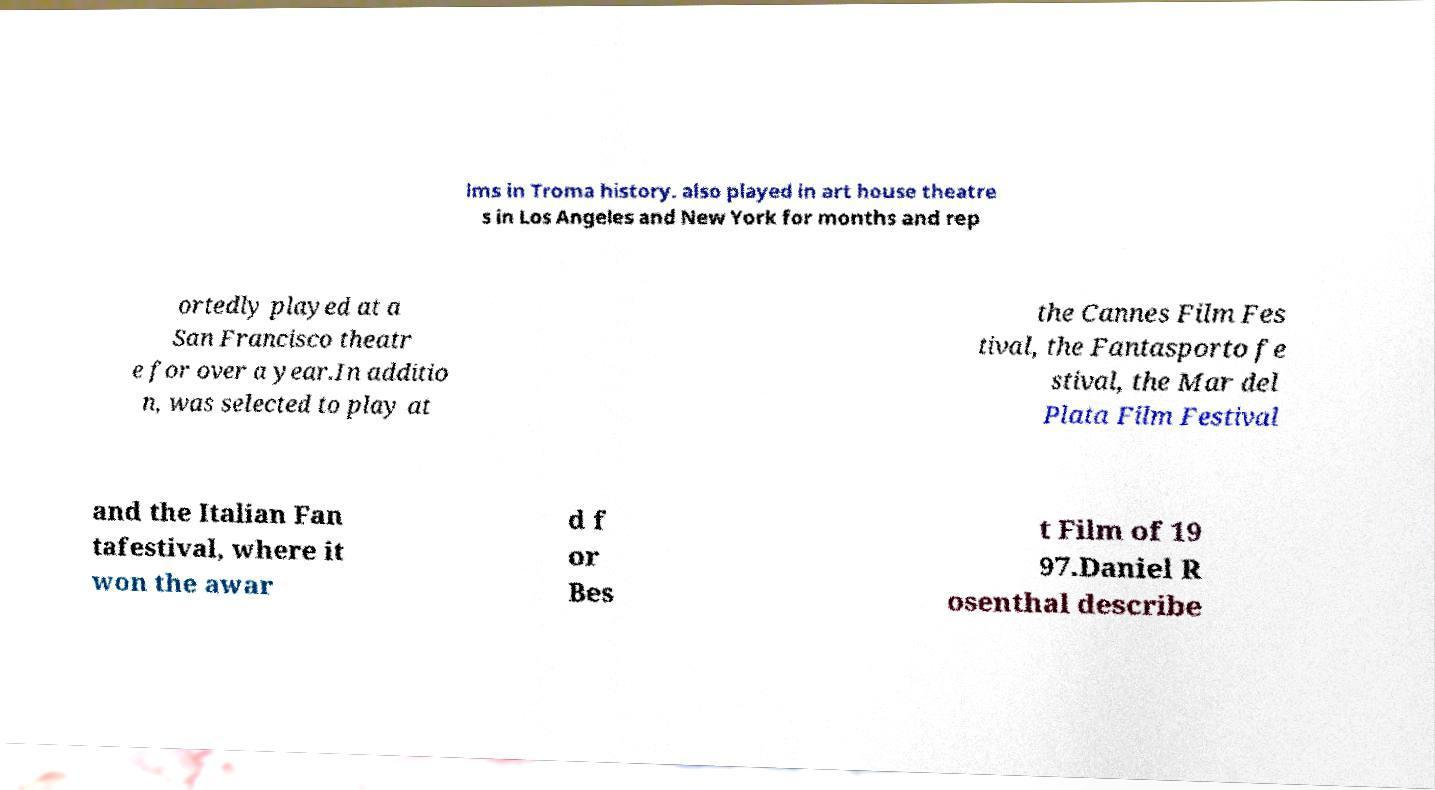Can you accurately transcribe the text from the provided image for me? lms in Troma history. also played in art house theatre s in Los Angeles and New York for months and rep ortedly played at a San Francisco theatr e for over a year.In additio n, was selected to play at the Cannes Film Fes tival, the Fantasporto fe stival, the Mar del Plata Film Festival and the Italian Fan tafestival, where it won the awar d f or Bes t Film of 19 97.Daniel R osenthal describe 